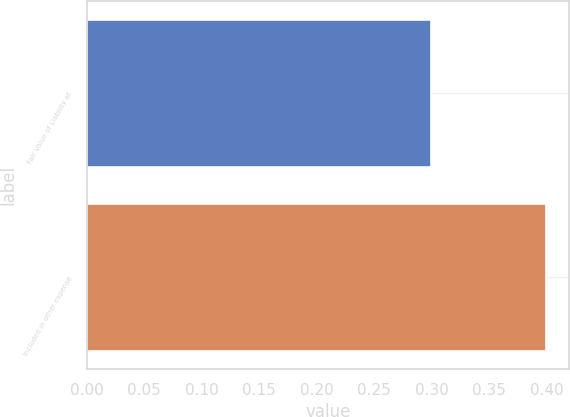<chart> <loc_0><loc_0><loc_500><loc_500><bar_chart><fcel>Fair Value of Liability at<fcel>Included in other expense<nl><fcel>0.3<fcel>0.4<nl></chart> 